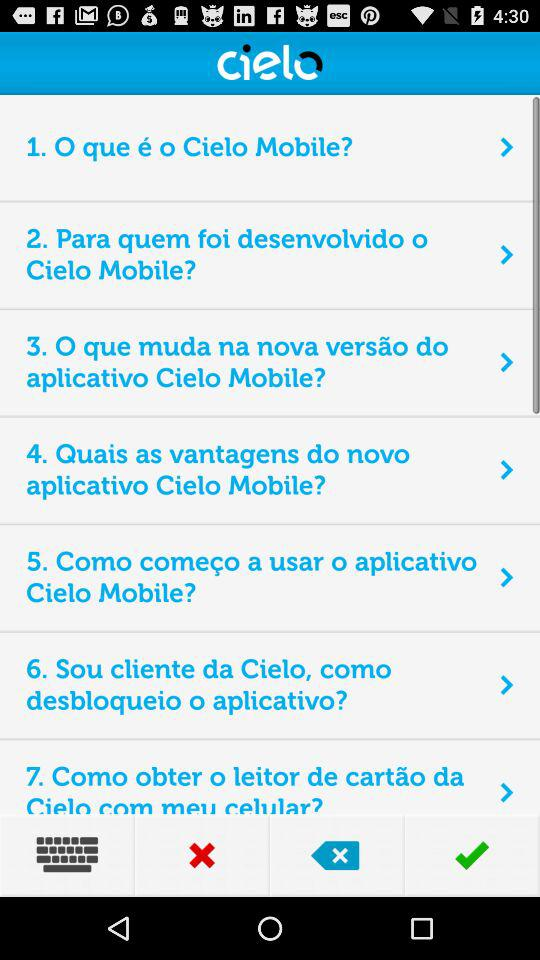How many questions are there in this FAQ?
Answer the question using a single word or phrase. 7 